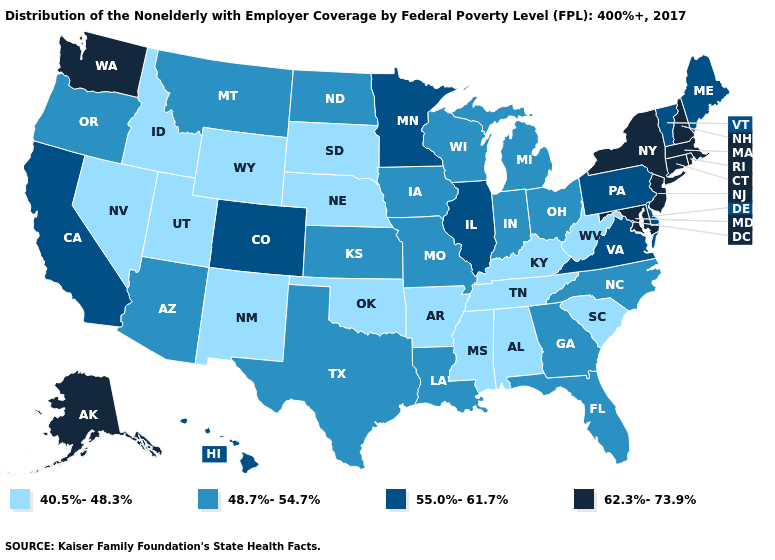Name the states that have a value in the range 48.7%-54.7%?
Write a very short answer. Arizona, Florida, Georgia, Indiana, Iowa, Kansas, Louisiana, Michigan, Missouri, Montana, North Carolina, North Dakota, Ohio, Oregon, Texas, Wisconsin. What is the highest value in the West ?
Concise answer only. 62.3%-73.9%. Does Rhode Island have a lower value than Maine?
Short answer required. No. What is the highest value in states that border Maryland?
Write a very short answer. 55.0%-61.7%. Which states have the highest value in the USA?
Write a very short answer. Alaska, Connecticut, Maryland, Massachusetts, New Hampshire, New Jersey, New York, Rhode Island, Washington. Does Mississippi have the lowest value in the USA?
Concise answer only. Yes. Name the states that have a value in the range 40.5%-48.3%?
Write a very short answer. Alabama, Arkansas, Idaho, Kentucky, Mississippi, Nebraska, Nevada, New Mexico, Oklahoma, South Carolina, South Dakota, Tennessee, Utah, West Virginia, Wyoming. What is the value of North Carolina?
Answer briefly. 48.7%-54.7%. Which states have the lowest value in the MidWest?
Concise answer only. Nebraska, South Dakota. What is the highest value in the USA?
Keep it brief. 62.3%-73.9%. Name the states that have a value in the range 40.5%-48.3%?
Give a very brief answer. Alabama, Arkansas, Idaho, Kentucky, Mississippi, Nebraska, Nevada, New Mexico, Oklahoma, South Carolina, South Dakota, Tennessee, Utah, West Virginia, Wyoming. What is the highest value in the USA?
Concise answer only. 62.3%-73.9%. What is the lowest value in states that border Illinois?
Quick response, please. 40.5%-48.3%. What is the highest value in states that border Colorado?
Be succinct. 48.7%-54.7%. What is the highest value in states that border Connecticut?
Give a very brief answer. 62.3%-73.9%. 